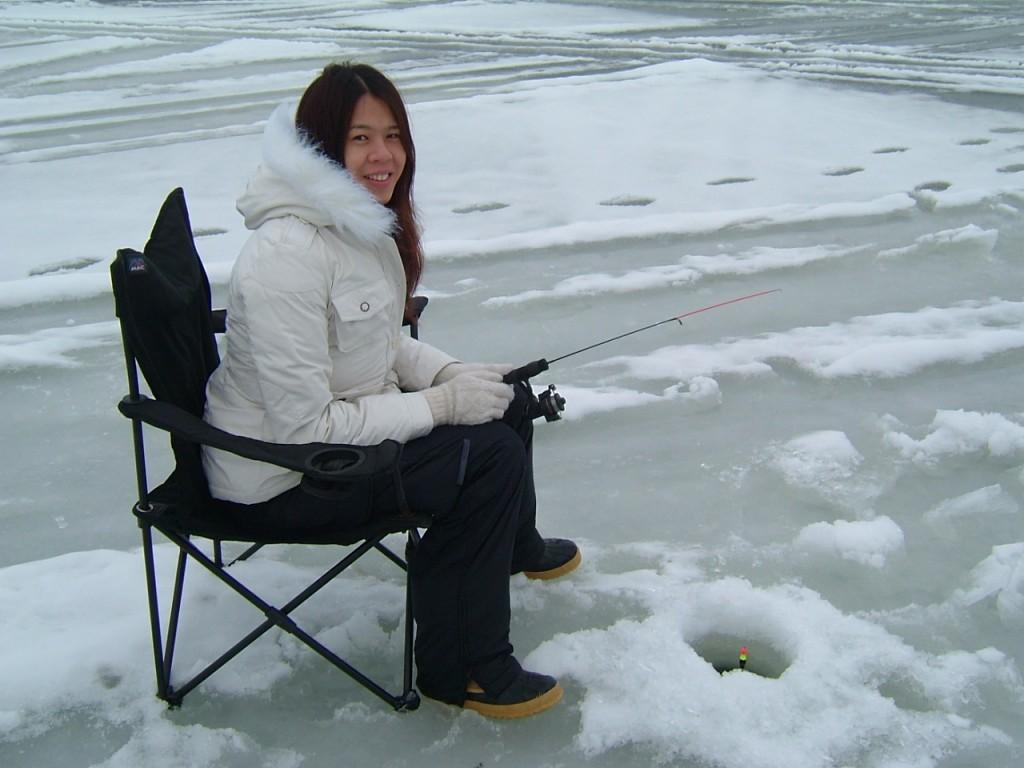Who is the main subject in the image? There is a lady in the image. What is the lady doing in the image? The lady is sitting on a chair and holding a fishing rod. What is the lady wearing in the image? The lady is wearing gloves and a jacket. What is the condition of the ground in the image? The ground is covered with snow. What type of cake is the lady baking in the image? There is no cake present in the image, and the lady is not baking anything. 